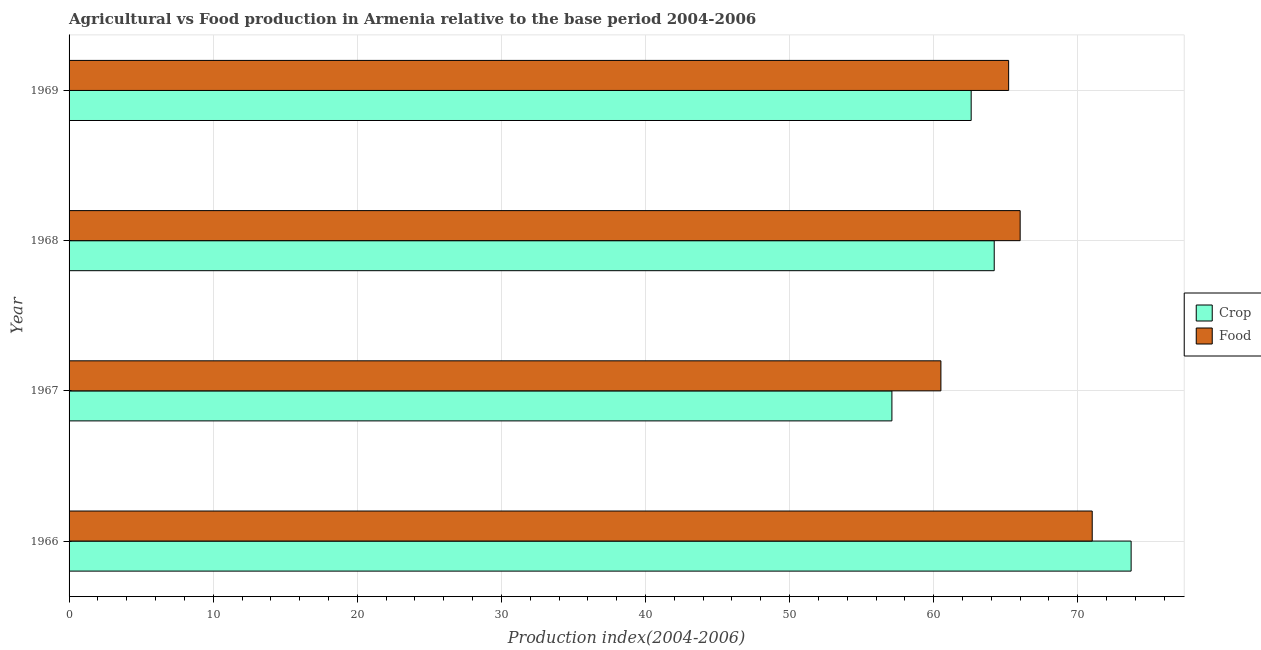How many different coloured bars are there?
Your answer should be very brief. 2. How many groups of bars are there?
Provide a short and direct response. 4. Are the number of bars per tick equal to the number of legend labels?
Your answer should be very brief. Yes. Are the number of bars on each tick of the Y-axis equal?
Keep it short and to the point. Yes. How many bars are there on the 3rd tick from the top?
Your answer should be compact. 2. How many bars are there on the 2nd tick from the bottom?
Your answer should be very brief. 2. What is the label of the 4th group of bars from the top?
Ensure brevity in your answer.  1966. What is the food production index in 1967?
Offer a very short reply. 60.5. Across all years, what is the maximum food production index?
Keep it short and to the point. 71. Across all years, what is the minimum crop production index?
Provide a succinct answer. 57.1. In which year was the crop production index maximum?
Give a very brief answer. 1966. In which year was the crop production index minimum?
Offer a very short reply. 1967. What is the total crop production index in the graph?
Offer a very short reply. 257.6. What is the difference between the crop production index in 1967 and the food production index in 1968?
Your answer should be very brief. -8.9. What is the average food production index per year?
Provide a succinct answer. 65.67. In how many years, is the crop production index greater than 34 ?
Offer a terse response. 4. What is the ratio of the food production index in 1967 to that in 1968?
Ensure brevity in your answer.  0.92. Is the difference between the crop production index in 1966 and 1968 greater than the difference between the food production index in 1966 and 1968?
Ensure brevity in your answer.  Yes. What is the difference between the highest and the second highest crop production index?
Keep it short and to the point. 9.5. In how many years, is the food production index greater than the average food production index taken over all years?
Ensure brevity in your answer.  2. Is the sum of the crop production index in 1967 and 1968 greater than the maximum food production index across all years?
Provide a short and direct response. Yes. What does the 2nd bar from the top in 1968 represents?
Offer a very short reply. Crop. What does the 2nd bar from the bottom in 1968 represents?
Provide a succinct answer. Food. How many bars are there?
Offer a terse response. 8. What is the title of the graph?
Ensure brevity in your answer.  Agricultural vs Food production in Armenia relative to the base period 2004-2006. Does "Private creditors" appear as one of the legend labels in the graph?
Offer a terse response. No. What is the label or title of the X-axis?
Your answer should be compact. Production index(2004-2006). What is the Production index(2004-2006) in Crop in 1966?
Give a very brief answer. 73.7. What is the Production index(2004-2006) in Food in 1966?
Offer a terse response. 71. What is the Production index(2004-2006) of Crop in 1967?
Your answer should be very brief. 57.1. What is the Production index(2004-2006) in Food in 1967?
Your answer should be compact. 60.5. What is the Production index(2004-2006) in Crop in 1968?
Offer a terse response. 64.2. What is the Production index(2004-2006) of Crop in 1969?
Offer a very short reply. 62.6. What is the Production index(2004-2006) in Food in 1969?
Provide a short and direct response. 65.2. Across all years, what is the maximum Production index(2004-2006) of Crop?
Offer a very short reply. 73.7. Across all years, what is the maximum Production index(2004-2006) in Food?
Provide a short and direct response. 71. Across all years, what is the minimum Production index(2004-2006) in Crop?
Provide a succinct answer. 57.1. Across all years, what is the minimum Production index(2004-2006) of Food?
Your answer should be very brief. 60.5. What is the total Production index(2004-2006) of Crop in the graph?
Offer a terse response. 257.6. What is the total Production index(2004-2006) of Food in the graph?
Offer a very short reply. 262.7. What is the difference between the Production index(2004-2006) of Crop in 1966 and that in 1967?
Give a very brief answer. 16.6. What is the difference between the Production index(2004-2006) in Food in 1966 and that in 1967?
Give a very brief answer. 10.5. What is the difference between the Production index(2004-2006) in Crop in 1966 and that in 1969?
Offer a terse response. 11.1. What is the difference between the Production index(2004-2006) in Food in 1967 and that in 1968?
Ensure brevity in your answer.  -5.5. What is the difference between the Production index(2004-2006) of Crop in 1967 and that in 1969?
Provide a short and direct response. -5.5. What is the difference between the Production index(2004-2006) in Food in 1967 and that in 1969?
Provide a short and direct response. -4.7. What is the difference between the Production index(2004-2006) in Crop in 1966 and the Production index(2004-2006) in Food in 1967?
Offer a terse response. 13.2. What is the difference between the Production index(2004-2006) of Crop in 1967 and the Production index(2004-2006) of Food in 1969?
Provide a short and direct response. -8.1. What is the average Production index(2004-2006) in Crop per year?
Provide a succinct answer. 64.4. What is the average Production index(2004-2006) in Food per year?
Make the answer very short. 65.67. In the year 1966, what is the difference between the Production index(2004-2006) of Crop and Production index(2004-2006) of Food?
Make the answer very short. 2.7. In the year 1968, what is the difference between the Production index(2004-2006) in Crop and Production index(2004-2006) in Food?
Offer a very short reply. -1.8. What is the ratio of the Production index(2004-2006) in Crop in 1966 to that in 1967?
Make the answer very short. 1.29. What is the ratio of the Production index(2004-2006) of Food in 1966 to that in 1967?
Make the answer very short. 1.17. What is the ratio of the Production index(2004-2006) of Crop in 1966 to that in 1968?
Your response must be concise. 1.15. What is the ratio of the Production index(2004-2006) in Food in 1966 to that in 1968?
Provide a short and direct response. 1.08. What is the ratio of the Production index(2004-2006) in Crop in 1966 to that in 1969?
Offer a terse response. 1.18. What is the ratio of the Production index(2004-2006) in Food in 1966 to that in 1969?
Give a very brief answer. 1.09. What is the ratio of the Production index(2004-2006) in Crop in 1967 to that in 1968?
Offer a terse response. 0.89. What is the ratio of the Production index(2004-2006) of Crop in 1967 to that in 1969?
Offer a terse response. 0.91. What is the ratio of the Production index(2004-2006) in Food in 1967 to that in 1969?
Your response must be concise. 0.93. What is the ratio of the Production index(2004-2006) of Crop in 1968 to that in 1969?
Make the answer very short. 1.03. What is the ratio of the Production index(2004-2006) in Food in 1968 to that in 1969?
Give a very brief answer. 1.01. What is the difference between the highest and the second highest Production index(2004-2006) in Crop?
Your answer should be very brief. 9.5. What is the difference between the highest and the second highest Production index(2004-2006) of Food?
Your response must be concise. 5. What is the difference between the highest and the lowest Production index(2004-2006) of Food?
Your answer should be compact. 10.5. 